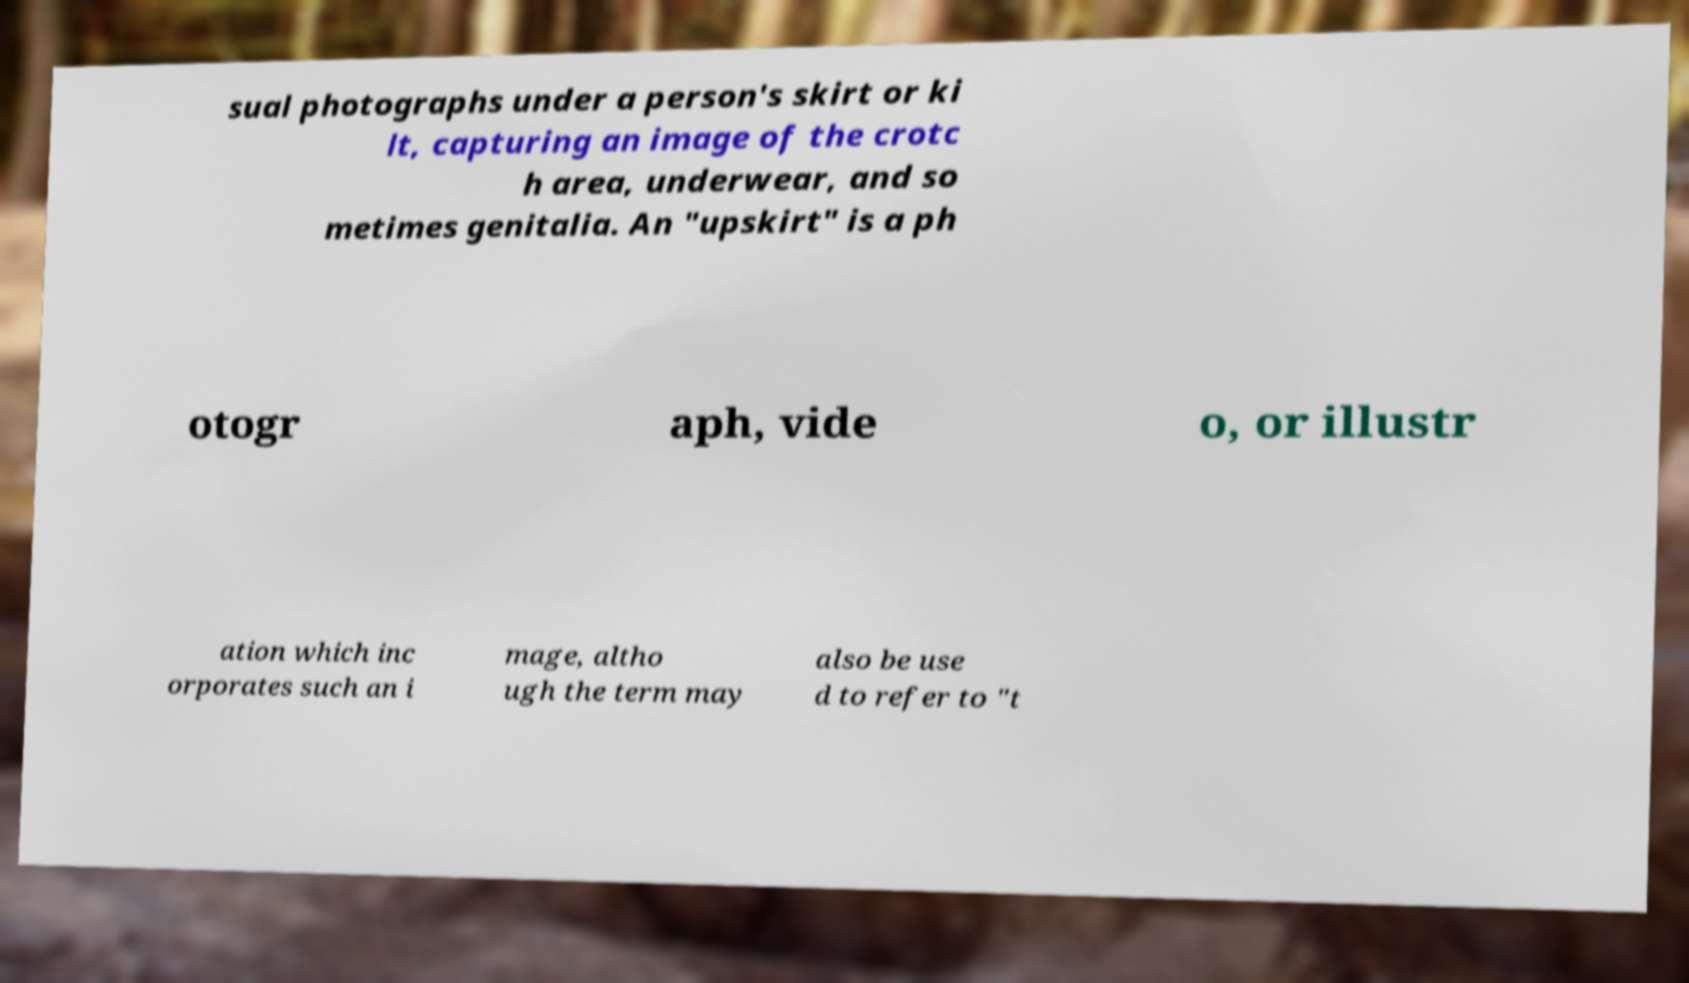For documentation purposes, I need the text within this image transcribed. Could you provide that? sual photographs under a person's skirt or ki lt, capturing an image of the crotc h area, underwear, and so metimes genitalia. An "upskirt" is a ph otogr aph, vide o, or illustr ation which inc orporates such an i mage, altho ugh the term may also be use d to refer to "t 